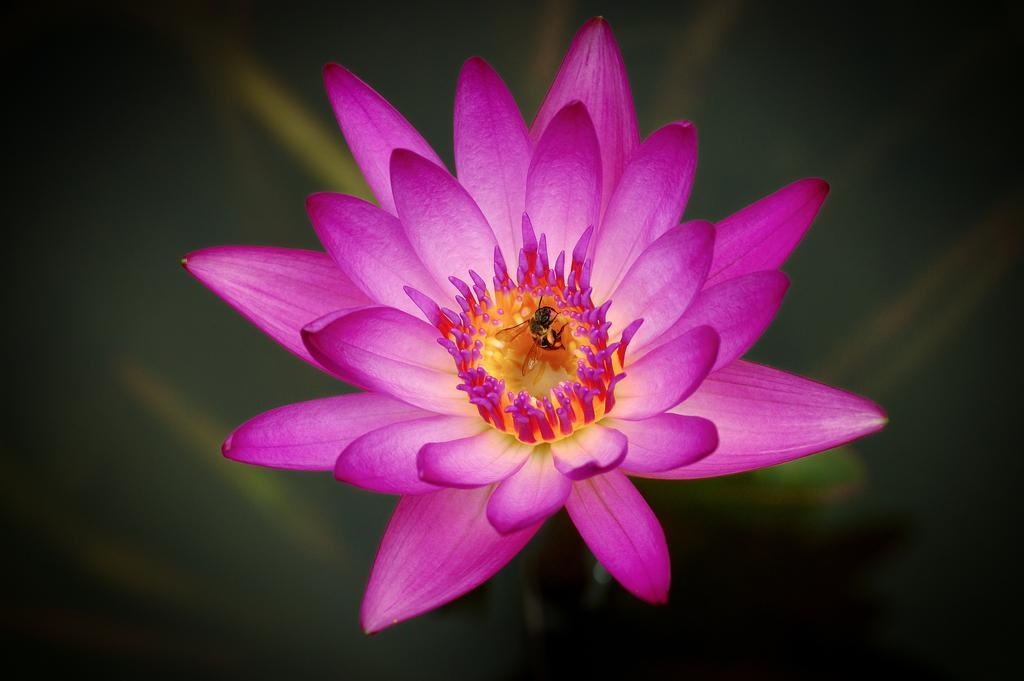In one or two sentences, can you explain what this image depicts? In the middle of the image we can see a flower and an insect, also we can see dark background. 